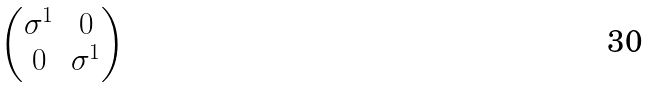<formula> <loc_0><loc_0><loc_500><loc_500>\begin{pmatrix} \sigma ^ { 1 } & 0 \\ 0 & \sigma ^ { 1 } \end{pmatrix}</formula> 